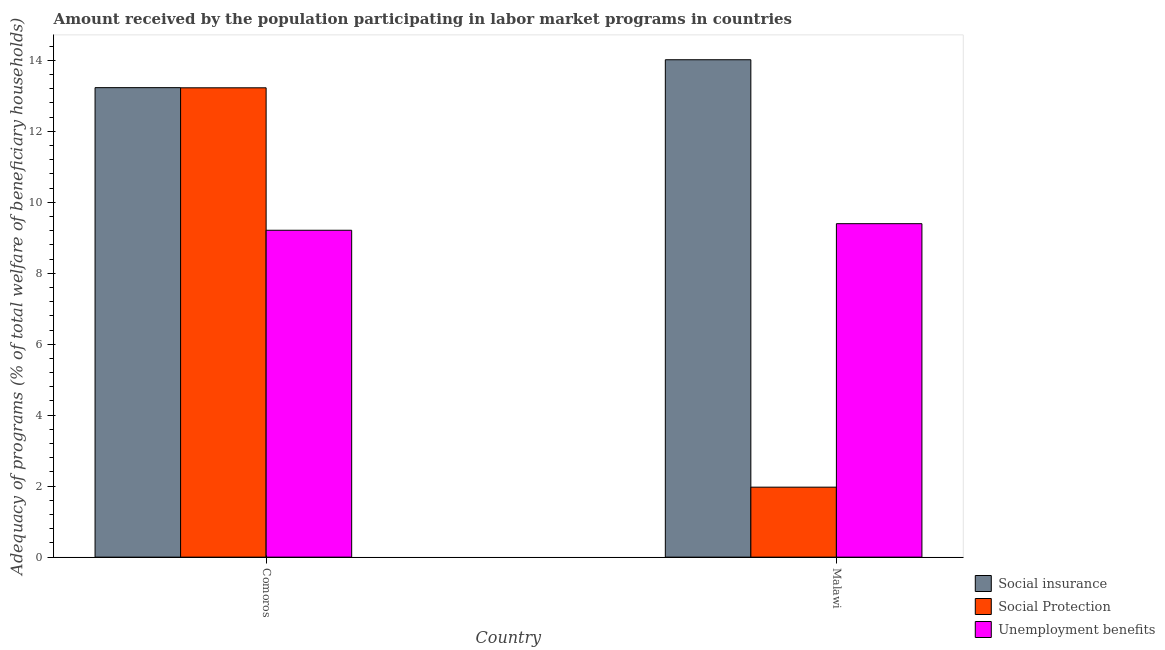How many different coloured bars are there?
Your response must be concise. 3. How many groups of bars are there?
Your answer should be compact. 2. Are the number of bars on each tick of the X-axis equal?
Ensure brevity in your answer.  Yes. How many bars are there on the 2nd tick from the left?
Your answer should be very brief. 3. What is the label of the 1st group of bars from the left?
Offer a terse response. Comoros. In how many cases, is the number of bars for a given country not equal to the number of legend labels?
Your answer should be very brief. 0. What is the amount received by the population participating in social insurance programs in Malawi?
Make the answer very short. 14.02. Across all countries, what is the maximum amount received by the population participating in social protection programs?
Keep it short and to the point. 13.22. Across all countries, what is the minimum amount received by the population participating in social insurance programs?
Your response must be concise. 13.23. In which country was the amount received by the population participating in social insurance programs maximum?
Make the answer very short. Malawi. In which country was the amount received by the population participating in unemployment benefits programs minimum?
Offer a terse response. Comoros. What is the total amount received by the population participating in social protection programs in the graph?
Your answer should be very brief. 15.2. What is the difference between the amount received by the population participating in social protection programs in Comoros and that in Malawi?
Offer a very short reply. 11.25. What is the difference between the amount received by the population participating in social protection programs in Comoros and the amount received by the population participating in unemployment benefits programs in Malawi?
Give a very brief answer. 3.83. What is the average amount received by the population participating in social insurance programs per country?
Your response must be concise. 13.62. What is the difference between the amount received by the population participating in social insurance programs and amount received by the population participating in social protection programs in Comoros?
Ensure brevity in your answer.  0. In how many countries, is the amount received by the population participating in social protection programs greater than 12.8 %?
Make the answer very short. 1. What is the ratio of the amount received by the population participating in social protection programs in Comoros to that in Malawi?
Your answer should be very brief. 6.71. What does the 1st bar from the left in Malawi represents?
Offer a very short reply. Social insurance. What does the 1st bar from the right in Malawi represents?
Ensure brevity in your answer.  Unemployment benefits. How many countries are there in the graph?
Offer a very short reply. 2. Does the graph contain grids?
Offer a terse response. No. What is the title of the graph?
Your response must be concise. Amount received by the population participating in labor market programs in countries. What is the label or title of the X-axis?
Offer a very short reply. Country. What is the label or title of the Y-axis?
Your response must be concise. Adequacy of programs (% of total welfare of beneficiary households). What is the Adequacy of programs (% of total welfare of beneficiary households) of Social insurance in Comoros?
Your response must be concise. 13.23. What is the Adequacy of programs (% of total welfare of beneficiary households) in Social Protection in Comoros?
Ensure brevity in your answer.  13.22. What is the Adequacy of programs (% of total welfare of beneficiary households) of Unemployment benefits in Comoros?
Your response must be concise. 9.21. What is the Adequacy of programs (% of total welfare of beneficiary households) of Social insurance in Malawi?
Your answer should be compact. 14.02. What is the Adequacy of programs (% of total welfare of beneficiary households) in Social Protection in Malawi?
Your answer should be very brief. 1.97. What is the Adequacy of programs (% of total welfare of beneficiary households) of Unemployment benefits in Malawi?
Keep it short and to the point. 9.4. Across all countries, what is the maximum Adequacy of programs (% of total welfare of beneficiary households) in Social insurance?
Offer a very short reply. 14.02. Across all countries, what is the maximum Adequacy of programs (% of total welfare of beneficiary households) of Social Protection?
Ensure brevity in your answer.  13.22. Across all countries, what is the maximum Adequacy of programs (% of total welfare of beneficiary households) of Unemployment benefits?
Provide a short and direct response. 9.4. Across all countries, what is the minimum Adequacy of programs (% of total welfare of beneficiary households) of Social insurance?
Your answer should be compact. 13.23. Across all countries, what is the minimum Adequacy of programs (% of total welfare of beneficiary households) in Social Protection?
Your answer should be compact. 1.97. Across all countries, what is the minimum Adequacy of programs (% of total welfare of beneficiary households) in Unemployment benefits?
Offer a terse response. 9.21. What is the total Adequacy of programs (% of total welfare of beneficiary households) of Social insurance in the graph?
Keep it short and to the point. 27.24. What is the total Adequacy of programs (% of total welfare of beneficiary households) in Social Protection in the graph?
Make the answer very short. 15.2. What is the total Adequacy of programs (% of total welfare of beneficiary households) in Unemployment benefits in the graph?
Keep it short and to the point. 18.61. What is the difference between the Adequacy of programs (% of total welfare of beneficiary households) of Social insurance in Comoros and that in Malawi?
Provide a succinct answer. -0.79. What is the difference between the Adequacy of programs (% of total welfare of beneficiary households) of Social Protection in Comoros and that in Malawi?
Your answer should be compact. 11.25. What is the difference between the Adequacy of programs (% of total welfare of beneficiary households) in Unemployment benefits in Comoros and that in Malawi?
Ensure brevity in your answer.  -0.19. What is the difference between the Adequacy of programs (% of total welfare of beneficiary households) of Social insurance in Comoros and the Adequacy of programs (% of total welfare of beneficiary households) of Social Protection in Malawi?
Provide a short and direct response. 11.26. What is the difference between the Adequacy of programs (% of total welfare of beneficiary households) of Social insurance in Comoros and the Adequacy of programs (% of total welfare of beneficiary households) of Unemployment benefits in Malawi?
Ensure brevity in your answer.  3.83. What is the difference between the Adequacy of programs (% of total welfare of beneficiary households) of Social Protection in Comoros and the Adequacy of programs (% of total welfare of beneficiary households) of Unemployment benefits in Malawi?
Provide a short and direct response. 3.83. What is the average Adequacy of programs (% of total welfare of beneficiary households) in Social insurance per country?
Provide a short and direct response. 13.62. What is the average Adequacy of programs (% of total welfare of beneficiary households) in Social Protection per country?
Ensure brevity in your answer.  7.6. What is the average Adequacy of programs (% of total welfare of beneficiary households) of Unemployment benefits per country?
Give a very brief answer. 9.3. What is the difference between the Adequacy of programs (% of total welfare of beneficiary households) of Social insurance and Adequacy of programs (% of total welfare of beneficiary households) of Social Protection in Comoros?
Offer a very short reply. 0. What is the difference between the Adequacy of programs (% of total welfare of beneficiary households) of Social insurance and Adequacy of programs (% of total welfare of beneficiary households) of Unemployment benefits in Comoros?
Offer a terse response. 4.02. What is the difference between the Adequacy of programs (% of total welfare of beneficiary households) in Social Protection and Adequacy of programs (% of total welfare of beneficiary households) in Unemployment benefits in Comoros?
Provide a succinct answer. 4.01. What is the difference between the Adequacy of programs (% of total welfare of beneficiary households) of Social insurance and Adequacy of programs (% of total welfare of beneficiary households) of Social Protection in Malawi?
Your response must be concise. 12.04. What is the difference between the Adequacy of programs (% of total welfare of beneficiary households) of Social insurance and Adequacy of programs (% of total welfare of beneficiary households) of Unemployment benefits in Malawi?
Your answer should be compact. 4.62. What is the difference between the Adequacy of programs (% of total welfare of beneficiary households) in Social Protection and Adequacy of programs (% of total welfare of beneficiary households) in Unemployment benefits in Malawi?
Provide a succinct answer. -7.42. What is the ratio of the Adequacy of programs (% of total welfare of beneficiary households) of Social insurance in Comoros to that in Malawi?
Keep it short and to the point. 0.94. What is the ratio of the Adequacy of programs (% of total welfare of beneficiary households) in Social Protection in Comoros to that in Malawi?
Ensure brevity in your answer.  6.71. What is the ratio of the Adequacy of programs (% of total welfare of beneficiary households) of Unemployment benefits in Comoros to that in Malawi?
Give a very brief answer. 0.98. What is the difference between the highest and the second highest Adequacy of programs (% of total welfare of beneficiary households) of Social insurance?
Your answer should be compact. 0.79. What is the difference between the highest and the second highest Adequacy of programs (% of total welfare of beneficiary households) in Social Protection?
Your response must be concise. 11.25. What is the difference between the highest and the second highest Adequacy of programs (% of total welfare of beneficiary households) in Unemployment benefits?
Give a very brief answer. 0.19. What is the difference between the highest and the lowest Adequacy of programs (% of total welfare of beneficiary households) of Social insurance?
Offer a very short reply. 0.79. What is the difference between the highest and the lowest Adequacy of programs (% of total welfare of beneficiary households) of Social Protection?
Offer a terse response. 11.25. What is the difference between the highest and the lowest Adequacy of programs (% of total welfare of beneficiary households) of Unemployment benefits?
Your answer should be compact. 0.19. 